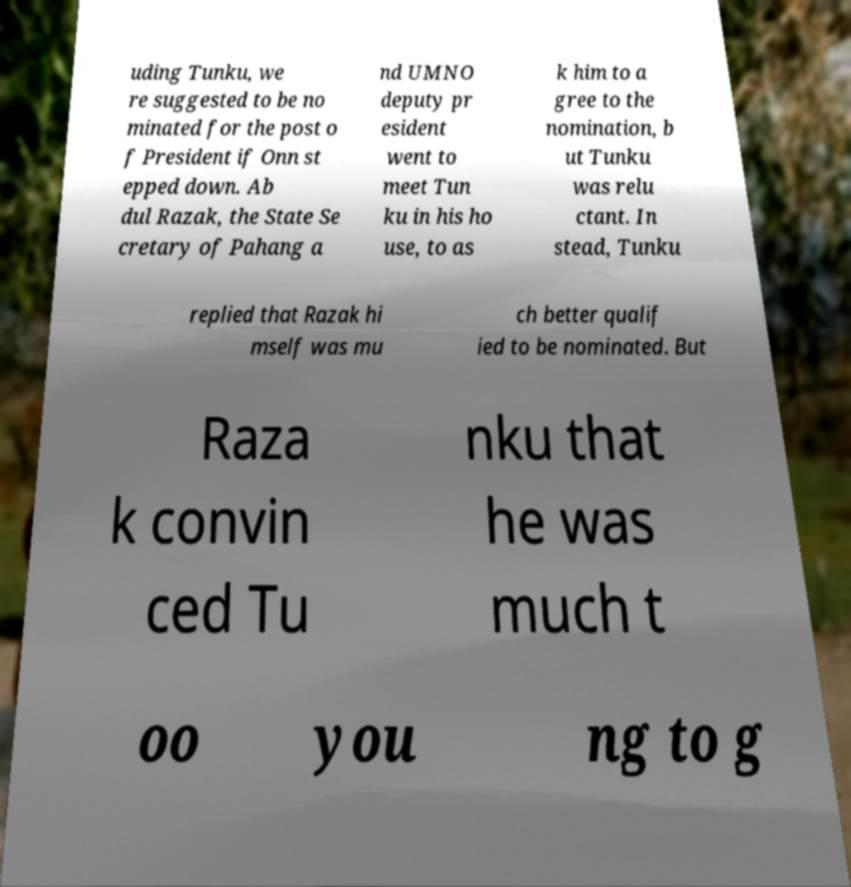There's text embedded in this image that I need extracted. Can you transcribe it verbatim? uding Tunku, we re suggested to be no minated for the post o f President if Onn st epped down. Ab dul Razak, the State Se cretary of Pahang a nd UMNO deputy pr esident went to meet Tun ku in his ho use, to as k him to a gree to the nomination, b ut Tunku was relu ctant. In stead, Tunku replied that Razak hi mself was mu ch better qualif ied to be nominated. But Raza k convin ced Tu nku that he was much t oo you ng to g 